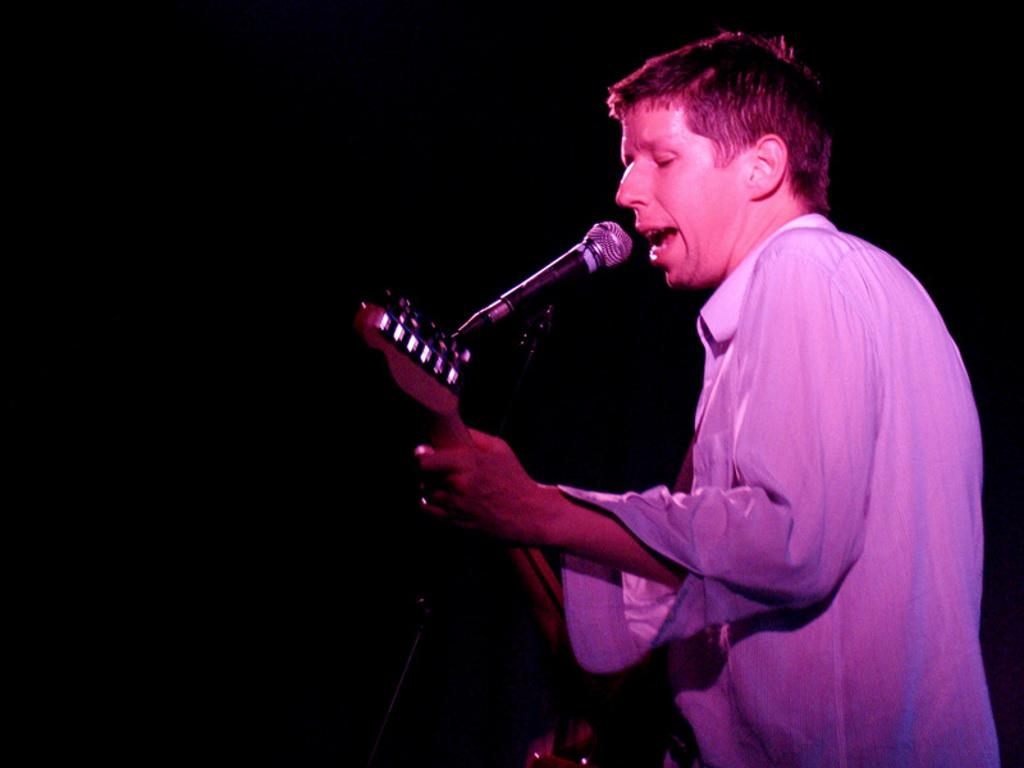What type of event is depicted in the image? The image is from a musical concert. Can you describe the person in the image? There is a man in the image, and he is wearing a white shirt. What instrument is the man holding? The man is holding a guitar. What is the man doing with the guitar? The man is playing the guitar. How is the man's voice being amplified in the image? The man is singing into a microphone. What type of vest is the man wearing in the image? The man is not wearing a vest in the image; he is wearing a white shirt. What does the town need to improve the concert experience? The image does not provide information about the town or any improvements needed for the concert experience. 